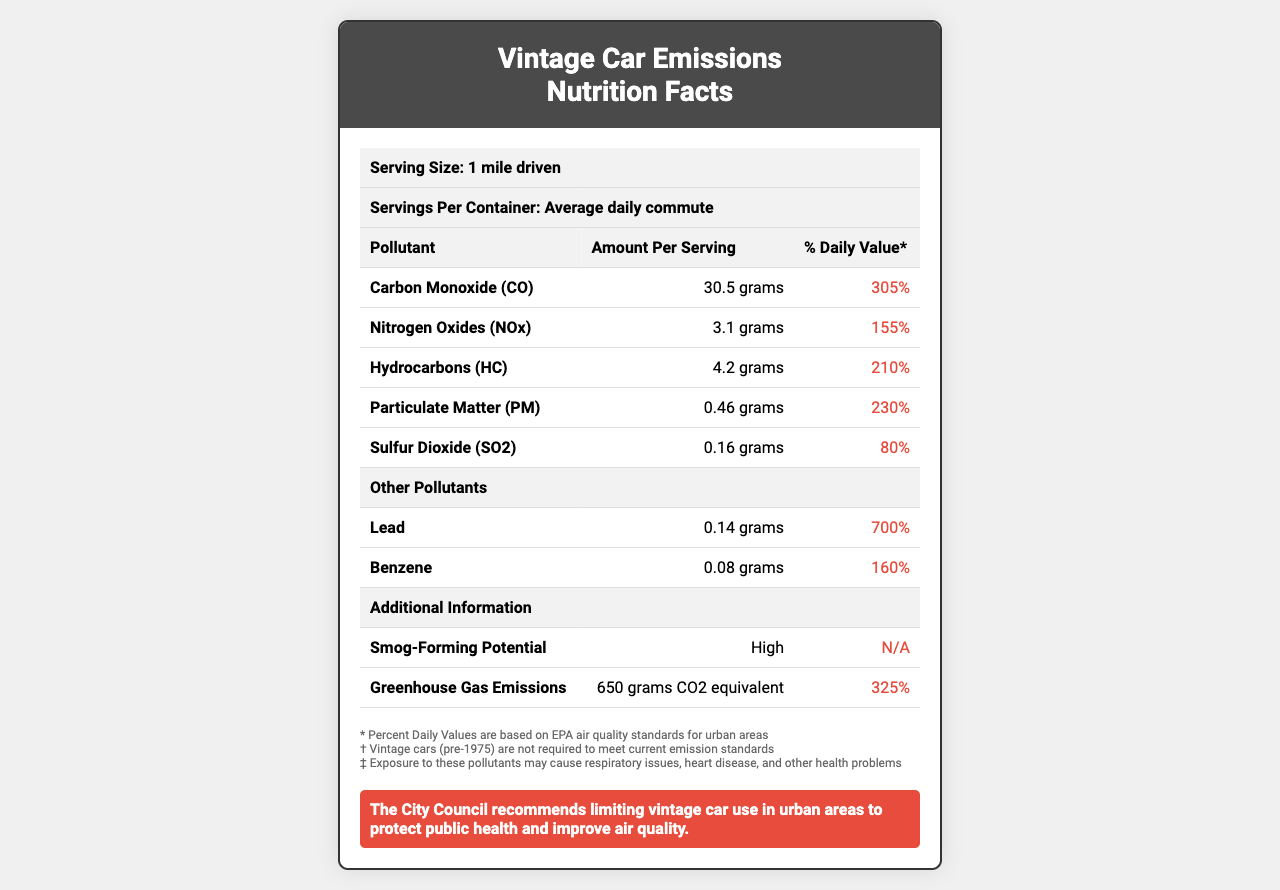what is the serving size mentioned in the document? The serving size listed at the top of the document is "1 mile driven."
Answer: 1 mile driven what pollutant has the highest % Daily Value? Under the "Other Pollutants" section, Lead has a % Daily Value of 700%, which is the highest.
Answer: Lead how much Carbon Monoxide (CO) is emitted per serving? The document lists Carbon Monoxide (CO) emissions as 30.5 grams per serving.
Answer: 30.5 grams what is the amount of Sulfur Dioxide (SO2) in grams? The amount of Sulfur Dioxide (SO2) listed is 0.16 grams per serving.
Answer: 0.16 grams what additional information is provided regarding greenhouse gas emissions? The "Greenhouse Gas Emissions" is listed with an amount of "650 grams CO2 equivalent."
Answer: 650 grams CO2 equivalent what is the daily value percentage for Hydrocarbons (HC)? The document lists the daily value percentage for Hydrocarbons (HC) as 210%.
Answer: 210% how can vintage car use affect public health according to the document? The footnotes indicate that exposure to these pollutants may cause respiratory issues, heart disease, and other health problems.
Answer: Exposure to pollutants may cause respiratory issues, heart disease, and other health problems what recommendation does the city council make regarding vintage car use? The regulatory statement at the bottom of the document recommends limiting vintage car use in urban areas.
Answer: Limiting vintage car use in urban areas what is the smog-forming potential listed as? The additional information section lists the smog-forming potential as "High."
Answer: High which of the following pollutants has the lowest % Daily Value? A. Carbon Monoxide (CO) B. Nitrogen Oxides (NOx) C. Sulfur Dioxide (SO2) D. Particulate Matter (PM) Sulfur Dioxide (SO2) has a % Daily Value of 80%, which is the lowest among the given options.
Answer: C. Sulfur Dioxide (SO2) which pollutant contributes 325% to the daily value of greenhouse gas emissions? A. Hydrocarbons (HC) B. Carbon Monoxide (CO) C. Nitrogen Oxides (NOx) D. Greenhouse Gas Emissions (CO2 equivalent) Greenhouse Gas Emissions (CO2 equivalent) is listed with a % Daily Value of 325%.
Answer: D. Greenhouse Gas Emissions (CO2 equivalent) are vintage cars (pre-1975) required to meet current emission standards? The footnote indicates that vintage cars (pre-1975) are not required to meet current emission standards.
Answer: No summarize the main idea of the document. The main idea is that the document compares vintage car exhaust emissions to a nutrition facts label, emphasizing the health impacts and recommending regulatory actions.
Answer: The document provides a detailed nutrition facts-like label for vintage car exhaust emissions, highlighting pollutant levels and their % Daily Value based on EPA air quality standards. It also includes additional information about smog-forming potential and greenhouse gas emissions, along with a regulatory statement recommending limiting vintage car use in urban areas to protect public health and improve air quality. how does the particulate matter (PM) emission compare to the % Daily Value suggested by EPA air quality standards? The document lists the particulate matter (PM) emission as 230% of the daily value, indicating that it exceeds EPA air quality standards significantly.
Answer: 230% is there enough information to determine the total daily emission of Carbon Monoxide (CO) for an average daily commute? The document provides the emission per mile driven but does not specify the total miles driven in an average daily commute, so the total daily emission cannot be determined.
Answer: No 